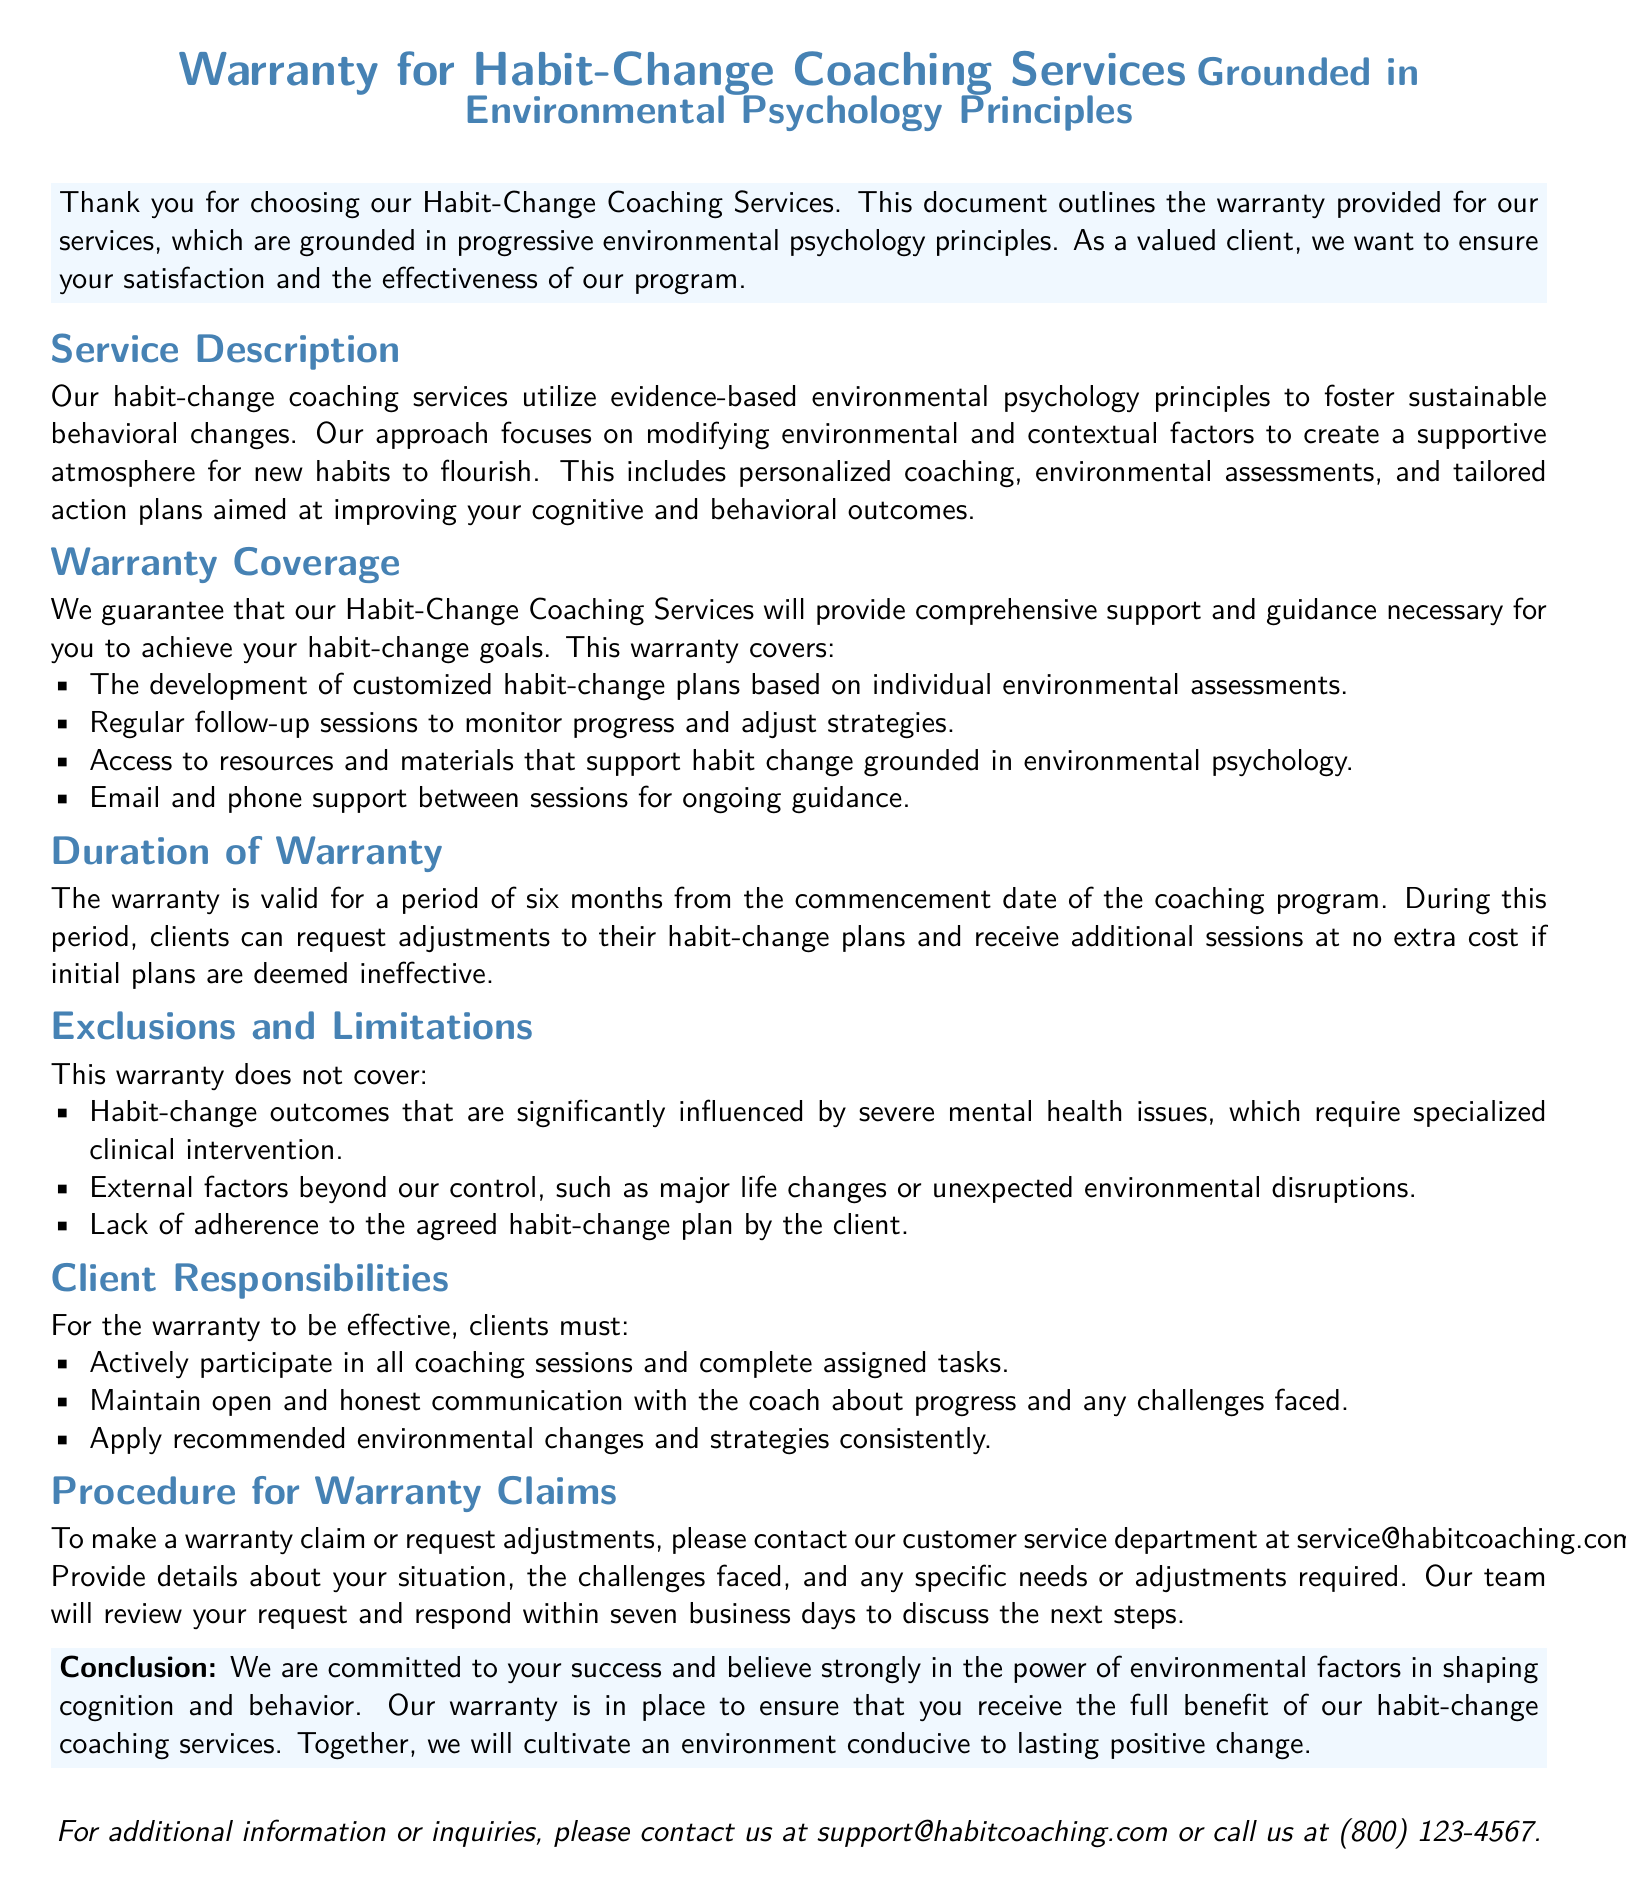What is the duration of the warranty? The document states the warranty is valid for a period of six months from the commencement date of the coaching program.
Answer: six months What is covered under the warranty? The warranty covers the development of customized habit-change plans and access to resources.
Answer: customized habit-change plans What is excluded from the warranty? The document lists exclusions such as severe mental health issues and lack of adherence to the plan.
Answer: severe mental health issues How can clients make a warranty claim? Clients can contact the customer service department via the provided email.
Answer: service@habitcoaching.com What is required from clients for the warranty to be effective? Clients must actively participate in coaching sessions and apply recommended strategies consistently.
Answer: actively participate What is the response time for warranty claims? The document specifies that the team will respond within seven business days.
Answer: seven business days What principles are the coaching services grounded in? The coaching services are grounded in environmental psychology principles.
Answer: environmental psychology principles What type of support does the warranty include? The warranty includes email and phone support between sessions for ongoing guidance.
Answer: email and phone support 